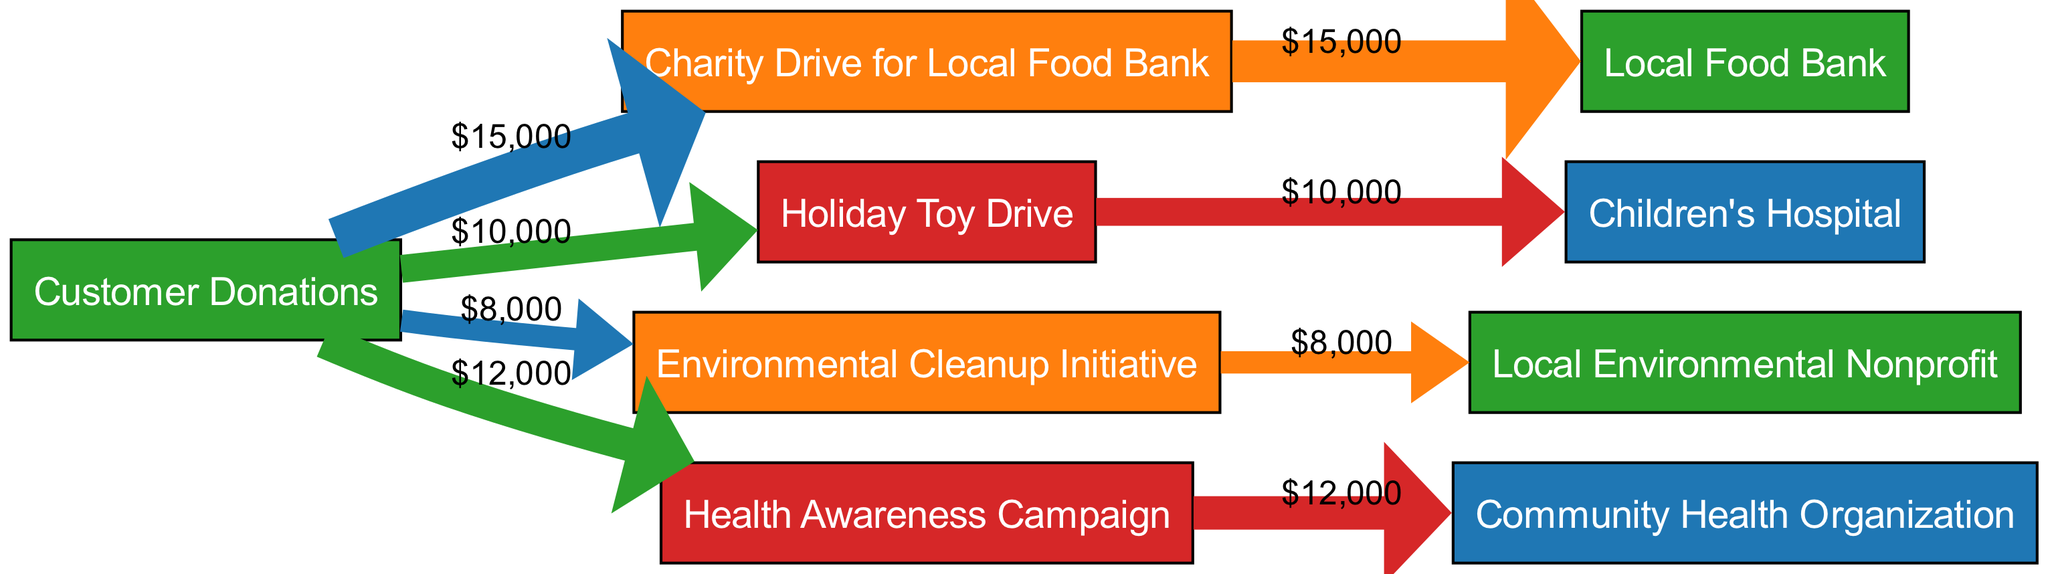What is the total amount generated from customer donations? By adding up all the values from the "Customer Donations" source, we have $15,000 for the Local Food Bank, $10,000 for the Holiday Toy Drive, $8,000 for the Environmental Cleanup Initiative, and $12,000 for the Health Awareness Campaign, which sums up to 15,000 + 10,000 + 8,000 + 12,000 = 45,000.
Answer: 45000 Which nonprofit organization received funds from the Holiday Toy Drive? The diagram shows that the "Holiday Toy Drive" leads to the "Children's Hospital," indicating that this is where the funds were allocated.
Answer: Children's Hospital How much was allocated to the Community Health Organization? The diagram indicates that the "Health Awareness Campaign" directed $12,000 to the "Community Health Organization," showing the specific allocation amount.
Answer: 12000 Which initiative had the least revenue generated from customer donations? Comparing the values: $15,000 (Local Food Bank), $10,000 (Holiday Toy Drive), $8,000 (Environmental Cleanup Initiative), and $12,000 (Health Awareness Campaign), the lowest amount is $8,000 for the Environmental Cleanup Initiative.
Answer: Environmental Cleanup Initiative How many nonprofit organizations received funds from customer donations? The diagram displays 4 unique paths from "Customer Donations" leading to 4 different nonprofit organizations, corresponding to the Local Food Bank, Children's Hospital, Local Environmental Nonprofit, and Community Health Organization.
Answer: 4 What percentage of total donations was allocated to the Local Food Bank? The total customer donations amount to $45,000. The Local Food Bank received $15,000. Therefore, the percentage allocated is (15,000 / 45,000) * 100 = 33.33%, which equates to one-third of the total.
Answer: 33.33% Which charity drive received the second-highest donation? Analyzing the donations: the Local Food Bank received $15,000, the Health Awareness Campaign received $12,000, the Holiday Toy Drive received $10,000, and the Environmental Cleanup Initiative received $8,000. The second-highest is therefore the Health Awareness Campaign with $12,000.
Answer: Health Awareness Campaign What is the total value of funds allocated to all nonprofit organizations combined? By summing allocations: $15,000 (Local Food Bank) + $10,000 (Children's Hospital) + $8,000 (Local Environmental Nonprofit) + $12,000 (Community Health Organization) gives a total of 15,000 + 10,000 + 8,000 + 12,000 = 45,000.
Answer: 45000 